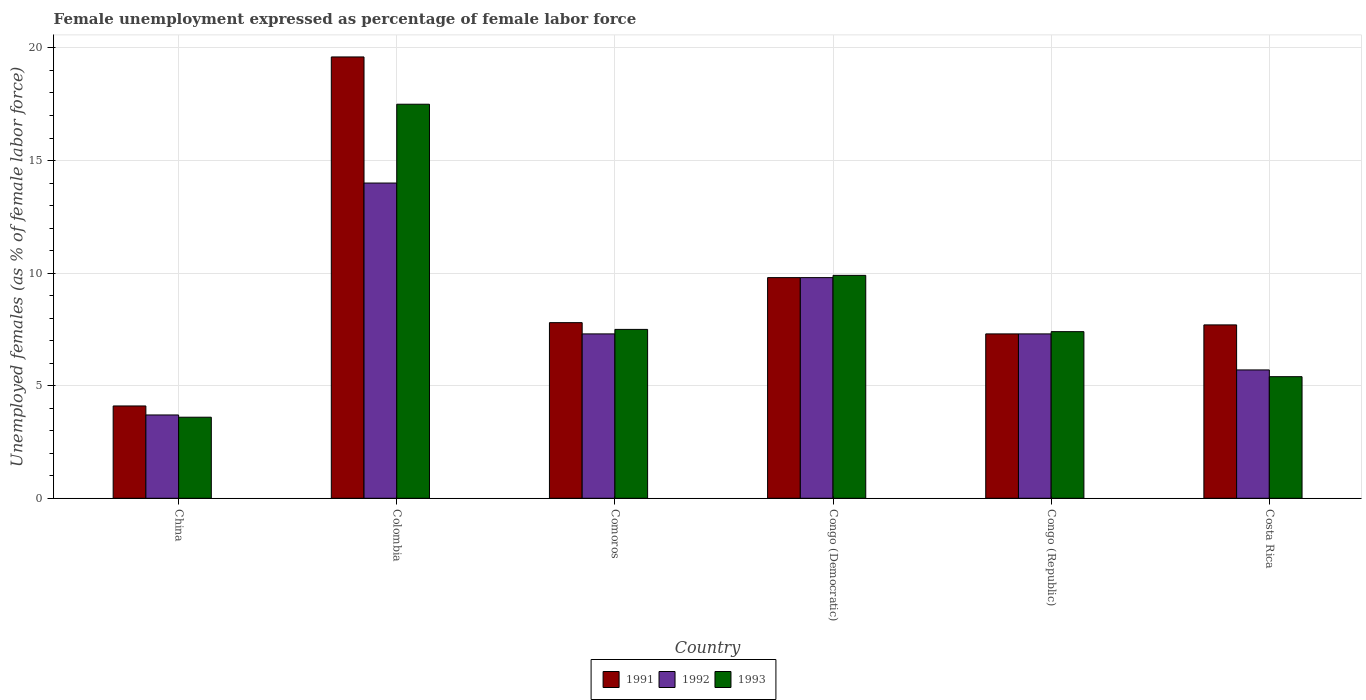How many different coloured bars are there?
Offer a very short reply. 3. Are the number of bars per tick equal to the number of legend labels?
Provide a short and direct response. Yes. Are the number of bars on each tick of the X-axis equal?
Give a very brief answer. Yes. How many bars are there on the 2nd tick from the left?
Your answer should be very brief. 3. What is the label of the 5th group of bars from the left?
Offer a terse response. Congo (Republic). In how many cases, is the number of bars for a given country not equal to the number of legend labels?
Make the answer very short. 0. What is the unemployment in females in in 1991 in Colombia?
Make the answer very short. 19.6. Across all countries, what is the minimum unemployment in females in in 1991?
Offer a very short reply. 4.1. In which country was the unemployment in females in in 1991 maximum?
Your answer should be very brief. Colombia. What is the total unemployment in females in in 1991 in the graph?
Offer a very short reply. 56.3. What is the difference between the unemployment in females in in 1993 in Colombia and that in Congo (Democratic)?
Offer a very short reply. 7.6. What is the difference between the unemployment in females in in 1992 in Congo (Republic) and the unemployment in females in in 1993 in China?
Give a very brief answer. 3.7. What is the average unemployment in females in in 1992 per country?
Make the answer very short. 7.97. What is the difference between the unemployment in females in of/in 1992 and unemployment in females in of/in 1991 in Colombia?
Offer a very short reply. -5.6. In how many countries, is the unemployment in females in in 1992 greater than 12 %?
Give a very brief answer. 1. What is the ratio of the unemployment in females in in 1993 in Comoros to that in Costa Rica?
Keep it short and to the point. 1.39. Is the difference between the unemployment in females in in 1992 in China and Congo (Republic) greater than the difference between the unemployment in females in in 1991 in China and Congo (Republic)?
Give a very brief answer. No. What is the difference between the highest and the second highest unemployment in females in in 1993?
Offer a very short reply. 7.6. What is the difference between the highest and the lowest unemployment in females in in 1993?
Your answer should be compact. 13.9. Is the sum of the unemployment in females in in 1992 in Congo (Democratic) and Congo (Republic) greater than the maximum unemployment in females in in 1991 across all countries?
Provide a succinct answer. No. What does the 1st bar from the right in China represents?
Your answer should be compact. 1993. How many bars are there?
Ensure brevity in your answer.  18. Are all the bars in the graph horizontal?
Your answer should be compact. No. What is the difference between two consecutive major ticks on the Y-axis?
Your answer should be compact. 5. Are the values on the major ticks of Y-axis written in scientific E-notation?
Your response must be concise. No. How are the legend labels stacked?
Ensure brevity in your answer.  Horizontal. What is the title of the graph?
Provide a succinct answer. Female unemployment expressed as percentage of female labor force. Does "1999" appear as one of the legend labels in the graph?
Make the answer very short. No. What is the label or title of the X-axis?
Your answer should be compact. Country. What is the label or title of the Y-axis?
Ensure brevity in your answer.  Unemployed females (as % of female labor force). What is the Unemployed females (as % of female labor force) of 1991 in China?
Ensure brevity in your answer.  4.1. What is the Unemployed females (as % of female labor force) in 1992 in China?
Give a very brief answer. 3.7. What is the Unemployed females (as % of female labor force) of 1993 in China?
Your answer should be compact. 3.6. What is the Unemployed females (as % of female labor force) of 1991 in Colombia?
Give a very brief answer. 19.6. What is the Unemployed females (as % of female labor force) in 1993 in Colombia?
Your answer should be very brief. 17.5. What is the Unemployed females (as % of female labor force) in 1991 in Comoros?
Offer a terse response. 7.8. What is the Unemployed females (as % of female labor force) of 1992 in Comoros?
Your answer should be very brief. 7.3. What is the Unemployed females (as % of female labor force) in 1991 in Congo (Democratic)?
Make the answer very short. 9.8. What is the Unemployed females (as % of female labor force) of 1992 in Congo (Democratic)?
Give a very brief answer. 9.8. What is the Unemployed females (as % of female labor force) of 1993 in Congo (Democratic)?
Provide a succinct answer. 9.9. What is the Unemployed females (as % of female labor force) of 1991 in Congo (Republic)?
Offer a very short reply. 7.3. What is the Unemployed females (as % of female labor force) of 1992 in Congo (Republic)?
Offer a terse response. 7.3. What is the Unemployed females (as % of female labor force) in 1993 in Congo (Republic)?
Keep it short and to the point. 7.4. What is the Unemployed females (as % of female labor force) in 1991 in Costa Rica?
Your answer should be very brief. 7.7. What is the Unemployed females (as % of female labor force) in 1992 in Costa Rica?
Your answer should be very brief. 5.7. What is the Unemployed females (as % of female labor force) in 1993 in Costa Rica?
Provide a succinct answer. 5.4. Across all countries, what is the maximum Unemployed females (as % of female labor force) of 1991?
Provide a short and direct response. 19.6. Across all countries, what is the maximum Unemployed females (as % of female labor force) of 1992?
Offer a terse response. 14. Across all countries, what is the maximum Unemployed females (as % of female labor force) in 1993?
Provide a succinct answer. 17.5. Across all countries, what is the minimum Unemployed females (as % of female labor force) of 1991?
Ensure brevity in your answer.  4.1. Across all countries, what is the minimum Unemployed females (as % of female labor force) of 1992?
Provide a succinct answer. 3.7. Across all countries, what is the minimum Unemployed females (as % of female labor force) of 1993?
Offer a very short reply. 3.6. What is the total Unemployed females (as % of female labor force) in 1991 in the graph?
Offer a very short reply. 56.3. What is the total Unemployed females (as % of female labor force) in 1992 in the graph?
Provide a succinct answer. 47.8. What is the total Unemployed females (as % of female labor force) in 1993 in the graph?
Keep it short and to the point. 51.3. What is the difference between the Unemployed females (as % of female labor force) of 1991 in China and that in Colombia?
Offer a very short reply. -15.5. What is the difference between the Unemployed females (as % of female labor force) in 1992 in China and that in Colombia?
Make the answer very short. -10.3. What is the difference between the Unemployed females (as % of female labor force) of 1993 in China and that in Comoros?
Provide a succinct answer. -3.9. What is the difference between the Unemployed females (as % of female labor force) in 1991 in China and that in Congo (Democratic)?
Provide a succinct answer. -5.7. What is the difference between the Unemployed females (as % of female labor force) in 1993 in China and that in Congo (Democratic)?
Your response must be concise. -6.3. What is the difference between the Unemployed females (as % of female labor force) of 1991 in China and that in Congo (Republic)?
Your answer should be compact. -3.2. What is the difference between the Unemployed females (as % of female labor force) of 1993 in China and that in Congo (Republic)?
Your answer should be compact. -3.8. What is the difference between the Unemployed females (as % of female labor force) of 1991 in China and that in Costa Rica?
Make the answer very short. -3.6. What is the difference between the Unemployed females (as % of female labor force) of 1992 in China and that in Costa Rica?
Provide a succinct answer. -2. What is the difference between the Unemployed females (as % of female labor force) in 1993 in China and that in Costa Rica?
Make the answer very short. -1.8. What is the difference between the Unemployed females (as % of female labor force) of 1991 in Colombia and that in Comoros?
Your answer should be very brief. 11.8. What is the difference between the Unemployed females (as % of female labor force) of 1993 in Colombia and that in Comoros?
Ensure brevity in your answer.  10. What is the difference between the Unemployed females (as % of female labor force) of 1992 in Colombia and that in Congo (Democratic)?
Your answer should be very brief. 4.2. What is the difference between the Unemployed females (as % of female labor force) in 1993 in Colombia and that in Congo (Democratic)?
Your response must be concise. 7.6. What is the difference between the Unemployed females (as % of female labor force) of 1992 in Colombia and that in Congo (Republic)?
Offer a terse response. 6.7. What is the difference between the Unemployed females (as % of female labor force) of 1991 in Colombia and that in Costa Rica?
Offer a terse response. 11.9. What is the difference between the Unemployed females (as % of female labor force) in 1992 in Colombia and that in Costa Rica?
Give a very brief answer. 8.3. What is the difference between the Unemployed females (as % of female labor force) of 1991 in Comoros and that in Congo (Democratic)?
Provide a succinct answer. -2. What is the difference between the Unemployed females (as % of female labor force) of 1992 in Comoros and that in Congo (Democratic)?
Your response must be concise. -2.5. What is the difference between the Unemployed females (as % of female labor force) of 1992 in Comoros and that in Congo (Republic)?
Your response must be concise. 0. What is the difference between the Unemployed females (as % of female labor force) of 1992 in Comoros and that in Costa Rica?
Provide a short and direct response. 1.6. What is the difference between the Unemployed females (as % of female labor force) of 1991 in Congo (Democratic) and that in Costa Rica?
Keep it short and to the point. 2.1. What is the difference between the Unemployed females (as % of female labor force) in 1992 in Congo (Democratic) and that in Costa Rica?
Offer a terse response. 4.1. What is the difference between the Unemployed females (as % of female labor force) in 1991 in Congo (Republic) and that in Costa Rica?
Your answer should be very brief. -0.4. What is the difference between the Unemployed females (as % of female labor force) in 1992 in Congo (Republic) and that in Costa Rica?
Ensure brevity in your answer.  1.6. What is the difference between the Unemployed females (as % of female labor force) in 1991 in China and the Unemployed females (as % of female labor force) in 1993 in Colombia?
Make the answer very short. -13.4. What is the difference between the Unemployed females (as % of female labor force) in 1992 in China and the Unemployed females (as % of female labor force) in 1993 in Colombia?
Keep it short and to the point. -13.8. What is the difference between the Unemployed females (as % of female labor force) of 1991 in China and the Unemployed females (as % of female labor force) of 1993 in Congo (Democratic)?
Offer a very short reply. -5.8. What is the difference between the Unemployed females (as % of female labor force) in 1992 in China and the Unemployed females (as % of female labor force) in 1993 in Congo (Democratic)?
Offer a terse response. -6.2. What is the difference between the Unemployed females (as % of female labor force) of 1991 in China and the Unemployed females (as % of female labor force) of 1992 in Congo (Republic)?
Ensure brevity in your answer.  -3.2. What is the difference between the Unemployed females (as % of female labor force) of 1991 in China and the Unemployed females (as % of female labor force) of 1993 in Congo (Republic)?
Keep it short and to the point. -3.3. What is the difference between the Unemployed females (as % of female labor force) of 1992 in China and the Unemployed females (as % of female labor force) of 1993 in Congo (Republic)?
Your answer should be very brief. -3.7. What is the difference between the Unemployed females (as % of female labor force) of 1991 in China and the Unemployed females (as % of female labor force) of 1992 in Costa Rica?
Offer a very short reply. -1.6. What is the difference between the Unemployed females (as % of female labor force) in 1991 in Colombia and the Unemployed females (as % of female labor force) in 1992 in Comoros?
Provide a succinct answer. 12.3. What is the difference between the Unemployed females (as % of female labor force) in 1991 in Colombia and the Unemployed females (as % of female labor force) in 1993 in Comoros?
Provide a succinct answer. 12.1. What is the difference between the Unemployed females (as % of female labor force) of 1992 in Colombia and the Unemployed females (as % of female labor force) of 1993 in Comoros?
Offer a very short reply. 6.5. What is the difference between the Unemployed females (as % of female labor force) of 1991 in Colombia and the Unemployed females (as % of female labor force) of 1993 in Congo (Republic)?
Provide a succinct answer. 12.2. What is the difference between the Unemployed females (as % of female labor force) of 1991 in Colombia and the Unemployed females (as % of female labor force) of 1992 in Costa Rica?
Offer a very short reply. 13.9. What is the difference between the Unemployed females (as % of female labor force) of 1992 in Colombia and the Unemployed females (as % of female labor force) of 1993 in Costa Rica?
Offer a terse response. 8.6. What is the difference between the Unemployed females (as % of female labor force) of 1991 in Comoros and the Unemployed females (as % of female labor force) of 1992 in Congo (Democratic)?
Give a very brief answer. -2. What is the difference between the Unemployed females (as % of female labor force) in 1991 in Comoros and the Unemployed females (as % of female labor force) in 1993 in Congo (Democratic)?
Ensure brevity in your answer.  -2.1. What is the difference between the Unemployed females (as % of female labor force) of 1992 in Comoros and the Unemployed females (as % of female labor force) of 1993 in Congo (Democratic)?
Ensure brevity in your answer.  -2.6. What is the difference between the Unemployed females (as % of female labor force) in 1991 in Comoros and the Unemployed females (as % of female labor force) in 1992 in Congo (Republic)?
Keep it short and to the point. 0.5. What is the difference between the Unemployed females (as % of female labor force) in 1991 in Comoros and the Unemployed females (as % of female labor force) in 1993 in Congo (Republic)?
Your answer should be compact. 0.4. What is the difference between the Unemployed females (as % of female labor force) of 1992 in Comoros and the Unemployed females (as % of female labor force) of 1993 in Costa Rica?
Your response must be concise. 1.9. What is the difference between the Unemployed females (as % of female labor force) of 1991 in Congo (Democratic) and the Unemployed females (as % of female labor force) of 1993 in Congo (Republic)?
Offer a very short reply. 2.4. What is the difference between the Unemployed females (as % of female labor force) in 1992 in Congo (Democratic) and the Unemployed females (as % of female labor force) in 1993 in Costa Rica?
Offer a terse response. 4.4. What is the difference between the Unemployed females (as % of female labor force) of 1991 in Congo (Republic) and the Unemployed females (as % of female labor force) of 1992 in Costa Rica?
Your answer should be compact. 1.6. What is the difference between the Unemployed females (as % of female labor force) of 1991 in Congo (Republic) and the Unemployed females (as % of female labor force) of 1993 in Costa Rica?
Keep it short and to the point. 1.9. What is the difference between the Unemployed females (as % of female labor force) of 1992 in Congo (Republic) and the Unemployed females (as % of female labor force) of 1993 in Costa Rica?
Keep it short and to the point. 1.9. What is the average Unemployed females (as % of female labor force) of 1991 per country?
Keep it short and to the point. 9.38. What is the average Unemployed females (as % of female labor force) in 1992 per country?
Your response must be concise. 7.97. What is the average Unemployed females (as % of female labor force) of 1993 per country?
Your answer should be compact. 8.55. What is the difference between the Unemployed females (as % of female labor force) in 1991 and Unemployed females (as % of female labor force) in 1992 in China?
Offer a terse response. 0.4. What is the difference between the Unemployed females (as % of female labor force) of 1991 and Unemployed females (as % of female labor force) of 1993 in Colombia?
Provide a short and direct response. 2.1. What is the difference between the Unemployed females (as % of female labor force) of 1991 and Unemployed females (as % of female labor force) of 1992 in Congo (Democratic)?
Your response must be concise. 0. What is the difference between the Unemployed females (as % of female labor force) of 1991 and Unemployed females (as % of female labor force) of 1993 in Congo (Democratic)?
Provide a short and direct response. -0.1. What is the ratio of the Unemployed females (as % of female labor force) of 1991 in China to that in Colombia?
Ensure brevity in your answer.  0.21. What is the ratio of the Unemployed females (as % of female labor force) in 1992 in China to that in Colombia?
Offer a very short reply. 0.26. What is the ratio of the Unemployed females (as % of female labor force) of 1993 in China to that in Colombia?
Your answer should be very brief. 0.21. What is the ratio of the Unemployed females (as % of female labor force) in 1991 in China to that in Comoros?
Your answer should be compact. 0.53. What is the ratio of the Unemployed females (as % of female labor force) of 1992 in China to that in Comoros?
Offer a terse response. 0.51. What is the ratio of the Unemployed females (as % of female labor force) in 1993 in China to that in Comoros?
Provide a short and direct response. 0.48. What is the ratio of the Unemployed females (as % of female labor force) in 1991 in China to that in Congo (Democratic)?
Give a very brief answer. 0.42. What is the ratio of the Unemployed females (as % of female labor force) in 1992 in China to that in Congo (Democratic)?
Give a very brief answer. 0.38. What is the ratio of the Unemployed females (as % of female labor force) in 1993 in China to that in Congo (Democratic)?
Offer a very short reply. 0.36. What is the ratio of the Unemployed females (as % of female labor force) in 1991 in China to that in Congo (Republic)?
Your response must be concise. 0.56. What is the ratio of the Unemployed females (as % of female labor force) in 1992 in China to that in Congo (Republic)?
Provide a succinct answer. 0.51. What is the ratio of the Unemployed females (as % of female labor force) in 1993 in China to that in Congo (Republic)?
Give a very brief answer. 0.49. What is the ratio of the Unemployed females (as % of female labor force) in 1991 in China to that in Costa Rica?
Your answer should be compact. 0.53. What is the ratio of the Unemployed females (as % of female labor force) in 1992 in China to that in Costa Rica?
Give a very brief answer. 0.65. What is the ratio of the Unemployed females (as % of female labor force) of 1993 in China to that in Costa Rica?
Ensure brevity in your answer.  0.67. What is the ratio of the Unemployed females (as % of female labor force) in 1991 in Colombia to that in Comoros?
Your answer should be very brief. 2.51. What is the ratio of the Unemployed females (as % of female labor force) in 1992 in Colombia to that in Comoros?
Your response must be concise. 1.92. What is the ratio of the Unemployed females (as % of female labor force) of 1993 in Colombia to that in Comoros?
Keep it short and to the point. 2.33. What is the ratio of the Unemployed females (as % of female labor force) in 1992 in Colombia to that in Congo (Democratic)?
Give a very brief answer. 1.43. What is the ratio of the Unemployed females (as % of female labor force) in 1993 in Colombia to that in Congo (Democratic)?
Your answer should be very brief. 1.77. What is the ratio of the Unemployed females (as % of female labor force) of 1991 in Colombia to that in Congo (Republic)?
Make the answer very short. 2.68. What is the ratio of the Unemployed females (as % of female labor force) in 1992 in Colombia to that in Congo (Republic)?
Your response must be concise. 1.92. What is the ratio of the Unemployed females (as % of female labor force) of 1993 in Colombia to that in Congo (Republic)?
Your answer should be very brief. 2.36. What is the ratio of the Unemployed females (as % of female labor force) of 1991 in Colombia to that in Costa Rica?
Your answer should be compact. 2.55. What is the ratio of the Unemployed females (as % of female labor force) in 1992 in Colombia to that in Costa Rica?
Your answer should be compact. 2.46. What is the ratio of the Unemployed females (as % of female labor force) of 1993 in Colombia to that in Costa Rica?
Give a very brief answer. 3.24. What is the ratio of the Unemployed females (as % of female labor force) of 1991 in Comoros to that in Congo (Democratic)?
Your response must be concise. 0.8. What is the ratio of the Unemployed females (as % of female labor force) of 1992 in Comoros to that in Congo (Democratic)?
Offer a terse response. 0.74. What is the ratio of the Unemployed females (as % of female labor force) of 1993 in Comoros to that in Congo (Democratic)?
Make the answer very short. 0.76. What is the ratio of the Unemployed females (as % of female labor force) in 1991 in Comoros to that in Congo (Republic)?
Ensure brevity in your answer.  1.07. What is the ratio of the Unemployed females (as % of female labor force) of 1992 in Comoros to that in Congo (Republic)?
Provide a succinct answer. 1. What is the ratio of the Unemployed females (as % of female labor force) in 1993 in Comoros to that in Congo (Republic)?
Your answer should be compact. 1.01. What is the ratio of the Unemployed females (as % of female labor force) in 1992 in Comoros to that in Costa Rica?
Your response must be concise. 1.28. What is the ratio of the Unemployed females (as % of female labor force) of 1993 in Comoros to that in Costa Rica?
Give a very brief answer. 1.39. What is the ratio of the Unemployed females (as % of female labor force) of 1991 in Congo (Democratic) to that in Congo (Republic)?
Offer a very short reply. 1.34. What is the ratio of the Unemployed females (as % of female labor force) in 1992 in Congo (Democratic) to that in Congo (Republic)?
Give a very brief answer. 1.34. What is the ratio of the Unemployed females (as % of female labor force) of 1993 in Congo (Democratic) to that in Congo (Republic)?
Offer a very short reply. 1.34. What is the ratio of the Unemployed females (as % of female labor force) of 1991 in Congo (Democratic) to that in Costa Rica?
Your answer should be compact. 1.27. What is the ratio of the Unemployed females (as % of female labor force) in 1992 in Congo (Democratic) to that in Costa Rica?
Offer a very short reply. 1.72. What is the ratio of the Unemployed females (as % of female labor force) of 1993 in Congo (Democratic) to that in Costa Rica?
Your answer should be compact. 1.83. What is the ratio of the Unemployed females (as % of female labor force) in 1991 in Congo (Republic) to that in Costa Rica?
Offer a terse response. 0.95. What is the ratio of the Unemployed females (as % of female labor force) of 1992 in Congo (Republic) to that in Costa Rica?
Ensure brevity in your answer.  1.28. What is the ratio of the Unemployed females (as % of female labor force) in 1993 in Congo (Republic) to that in Costa Rica?
Offer a very short reply. 1.37. What is the difference between the highest and the lowest Unemployed females (as % of female labor force) of 1992?
Your answer should be compact. 10.3. What is the difference between the highest and the lowest Unemployed females (as % of female labor force) in 1993?
Give a very brief answer. 13.9. 